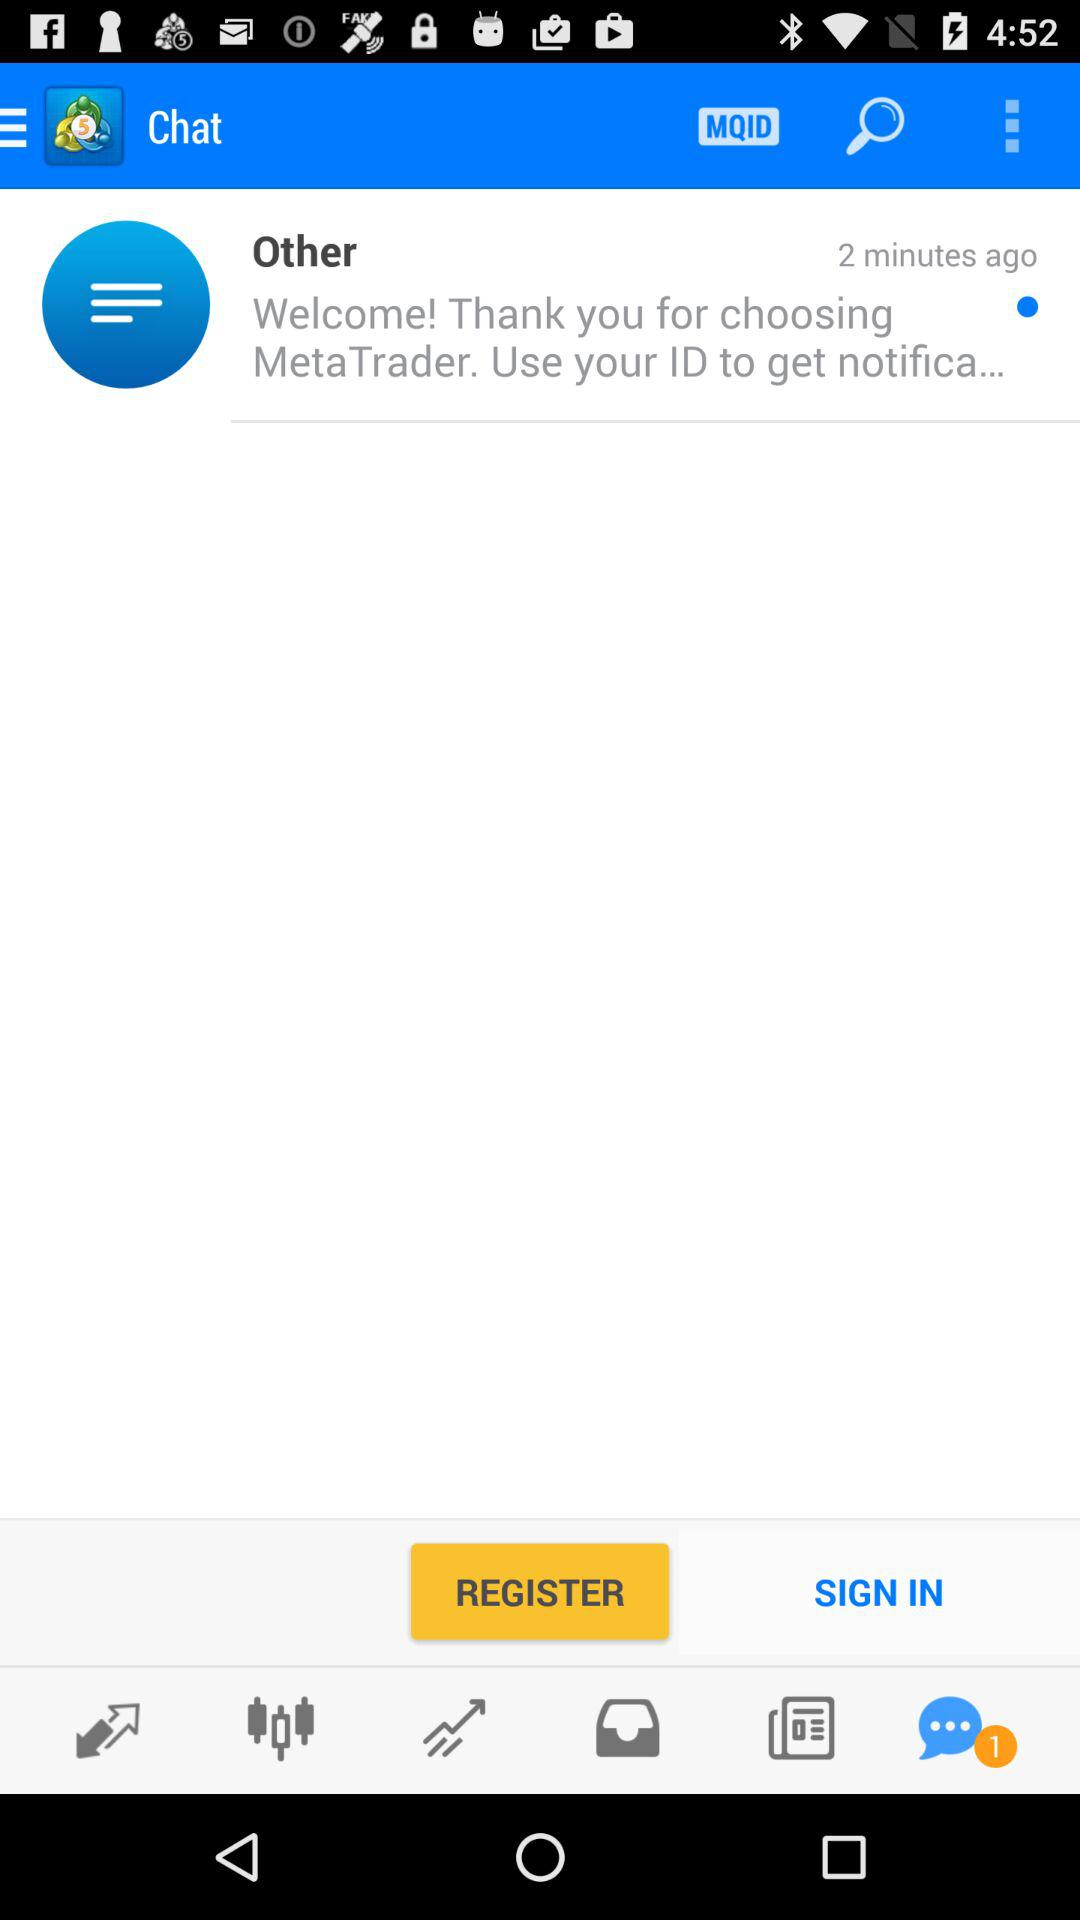When was the last update?
When the provided information is insufficient, respond with <no answer>. <no answer> 